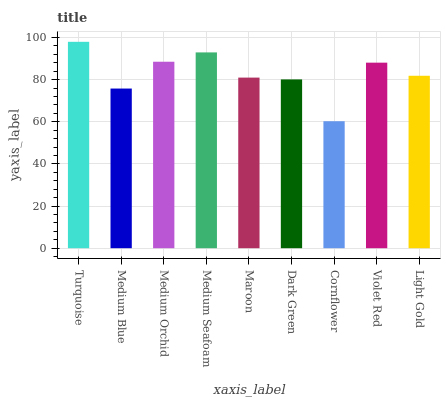Is Cornflower the minimum?
Answer yes or no. Yes. Is Turquoise the maximum?
Answer yes or no. Yes. Is Medium Blue the minimum?
Answer yes or no. No. Is Medium Blue the maximum?
Answer yes or no. No. Is Turquoise greater than Medium Blue?
Answer yes or no. Yes. Is Medium Blue less than Turquoise?
Answer yes or no. Yes. Is Medium Blue greater than Turquoise?
Answer yes or no. No. Is Turquoise less than Medium Blue?
Answer yes or no. No. Is Light Gold the high median?
Answer yes or no. Yes. Is Light Gold the low median?
Answer yes or no. Yes. Is Maroon the high median?
Answer yes or no. No. Is Turquoise the low median?
Answer yes or no. No. 